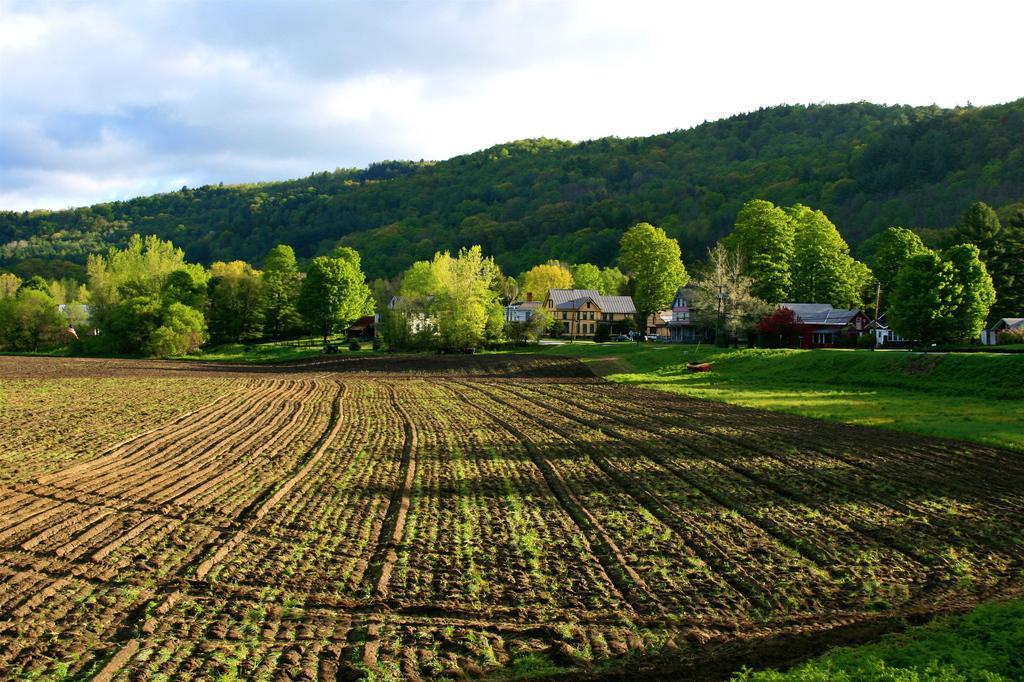How would you summarize this image in a sentence or two? In this image there are agricultural fields in the middle. In the background there are hills with the trees. On the right side there are houses beside the fields. At the top there is the sky. 